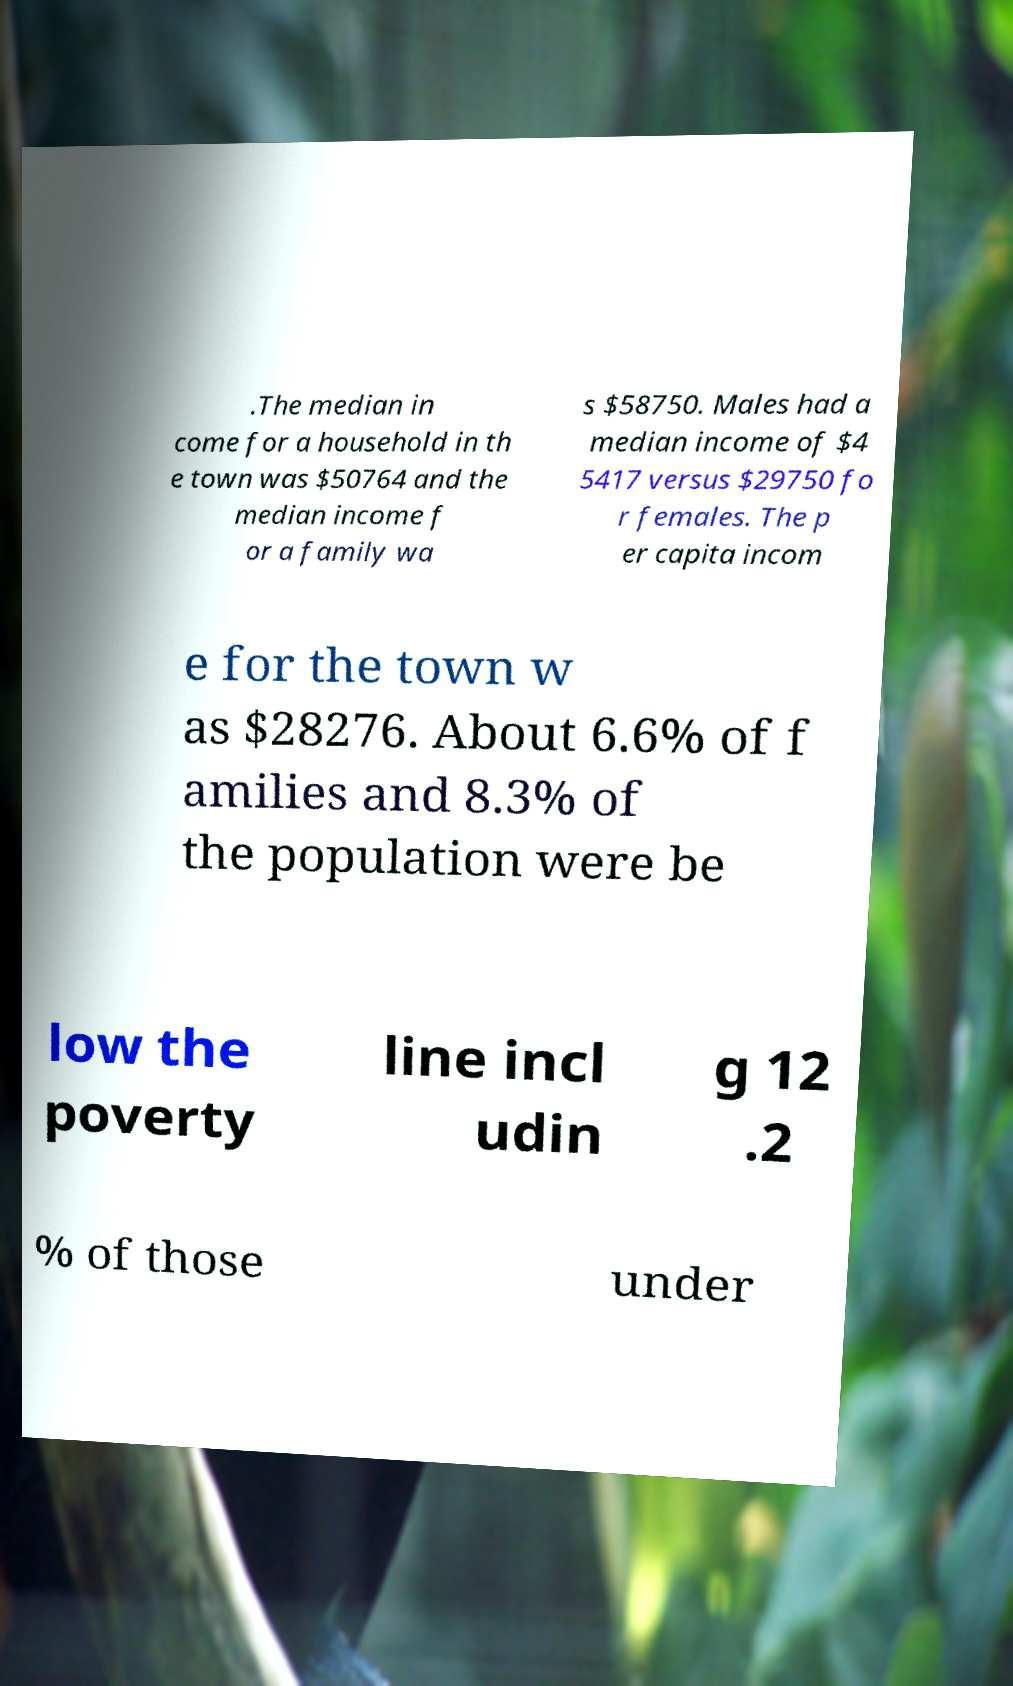Could you extract and type out the text from this image? .The median in come for a household in th e town was $50764 and the median income f or a family wa s $58750. Males had a median income of $4 5417 versus $29750 fo r females. The p er capita incom e for the town w as $28276. About 6.6% of f amilies and 8.3% of the population were be low the poverty line incl udin g 12 .2 % of those under 